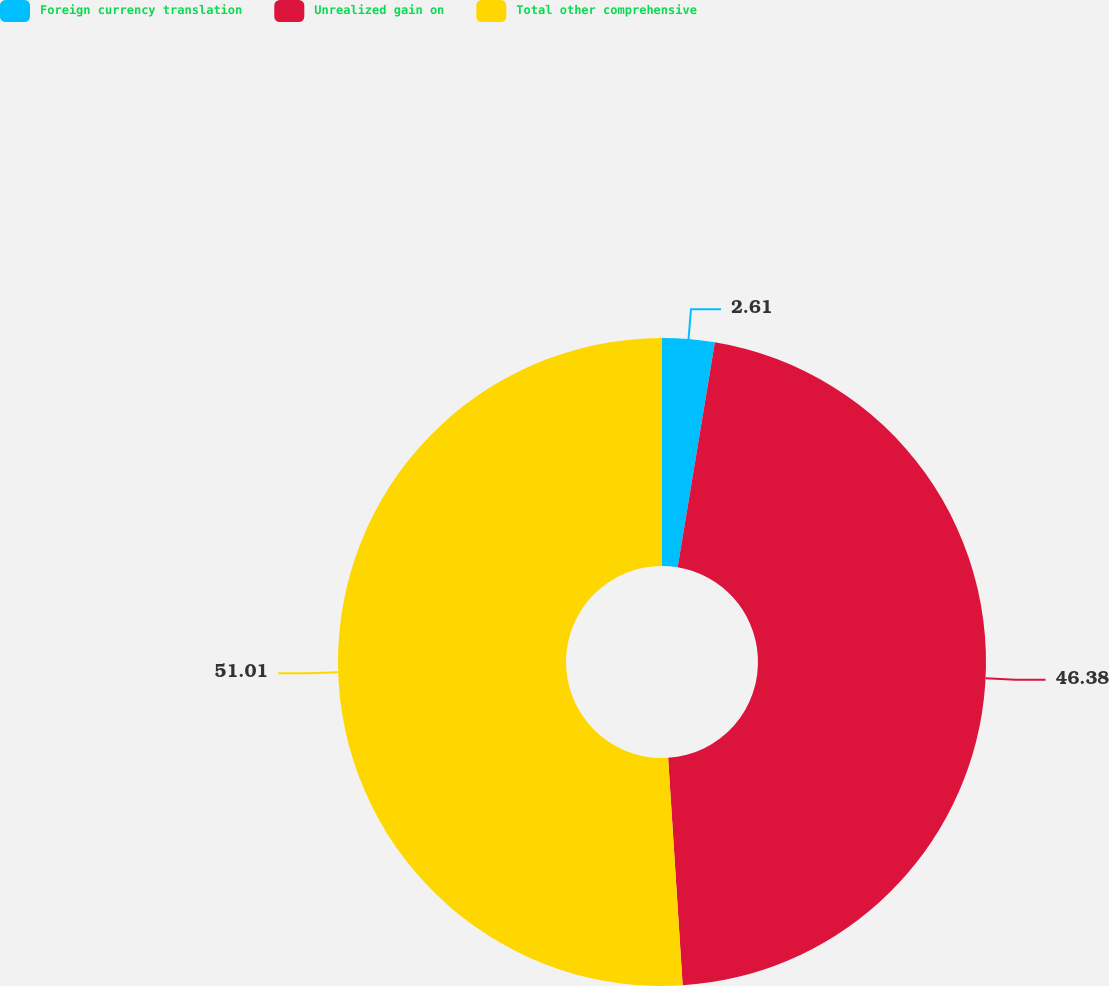Convert chart to OTSL. <chart><loc_0><loc_0><loc_500><loc_500><pie_chart><fcel>Foreign currency translation<fcel>Unrealized gain on<fcel>Total other comprehensive<nl><fcel>2.61%<fcel>46.38%<fcel>51.02%<nl></chart> 